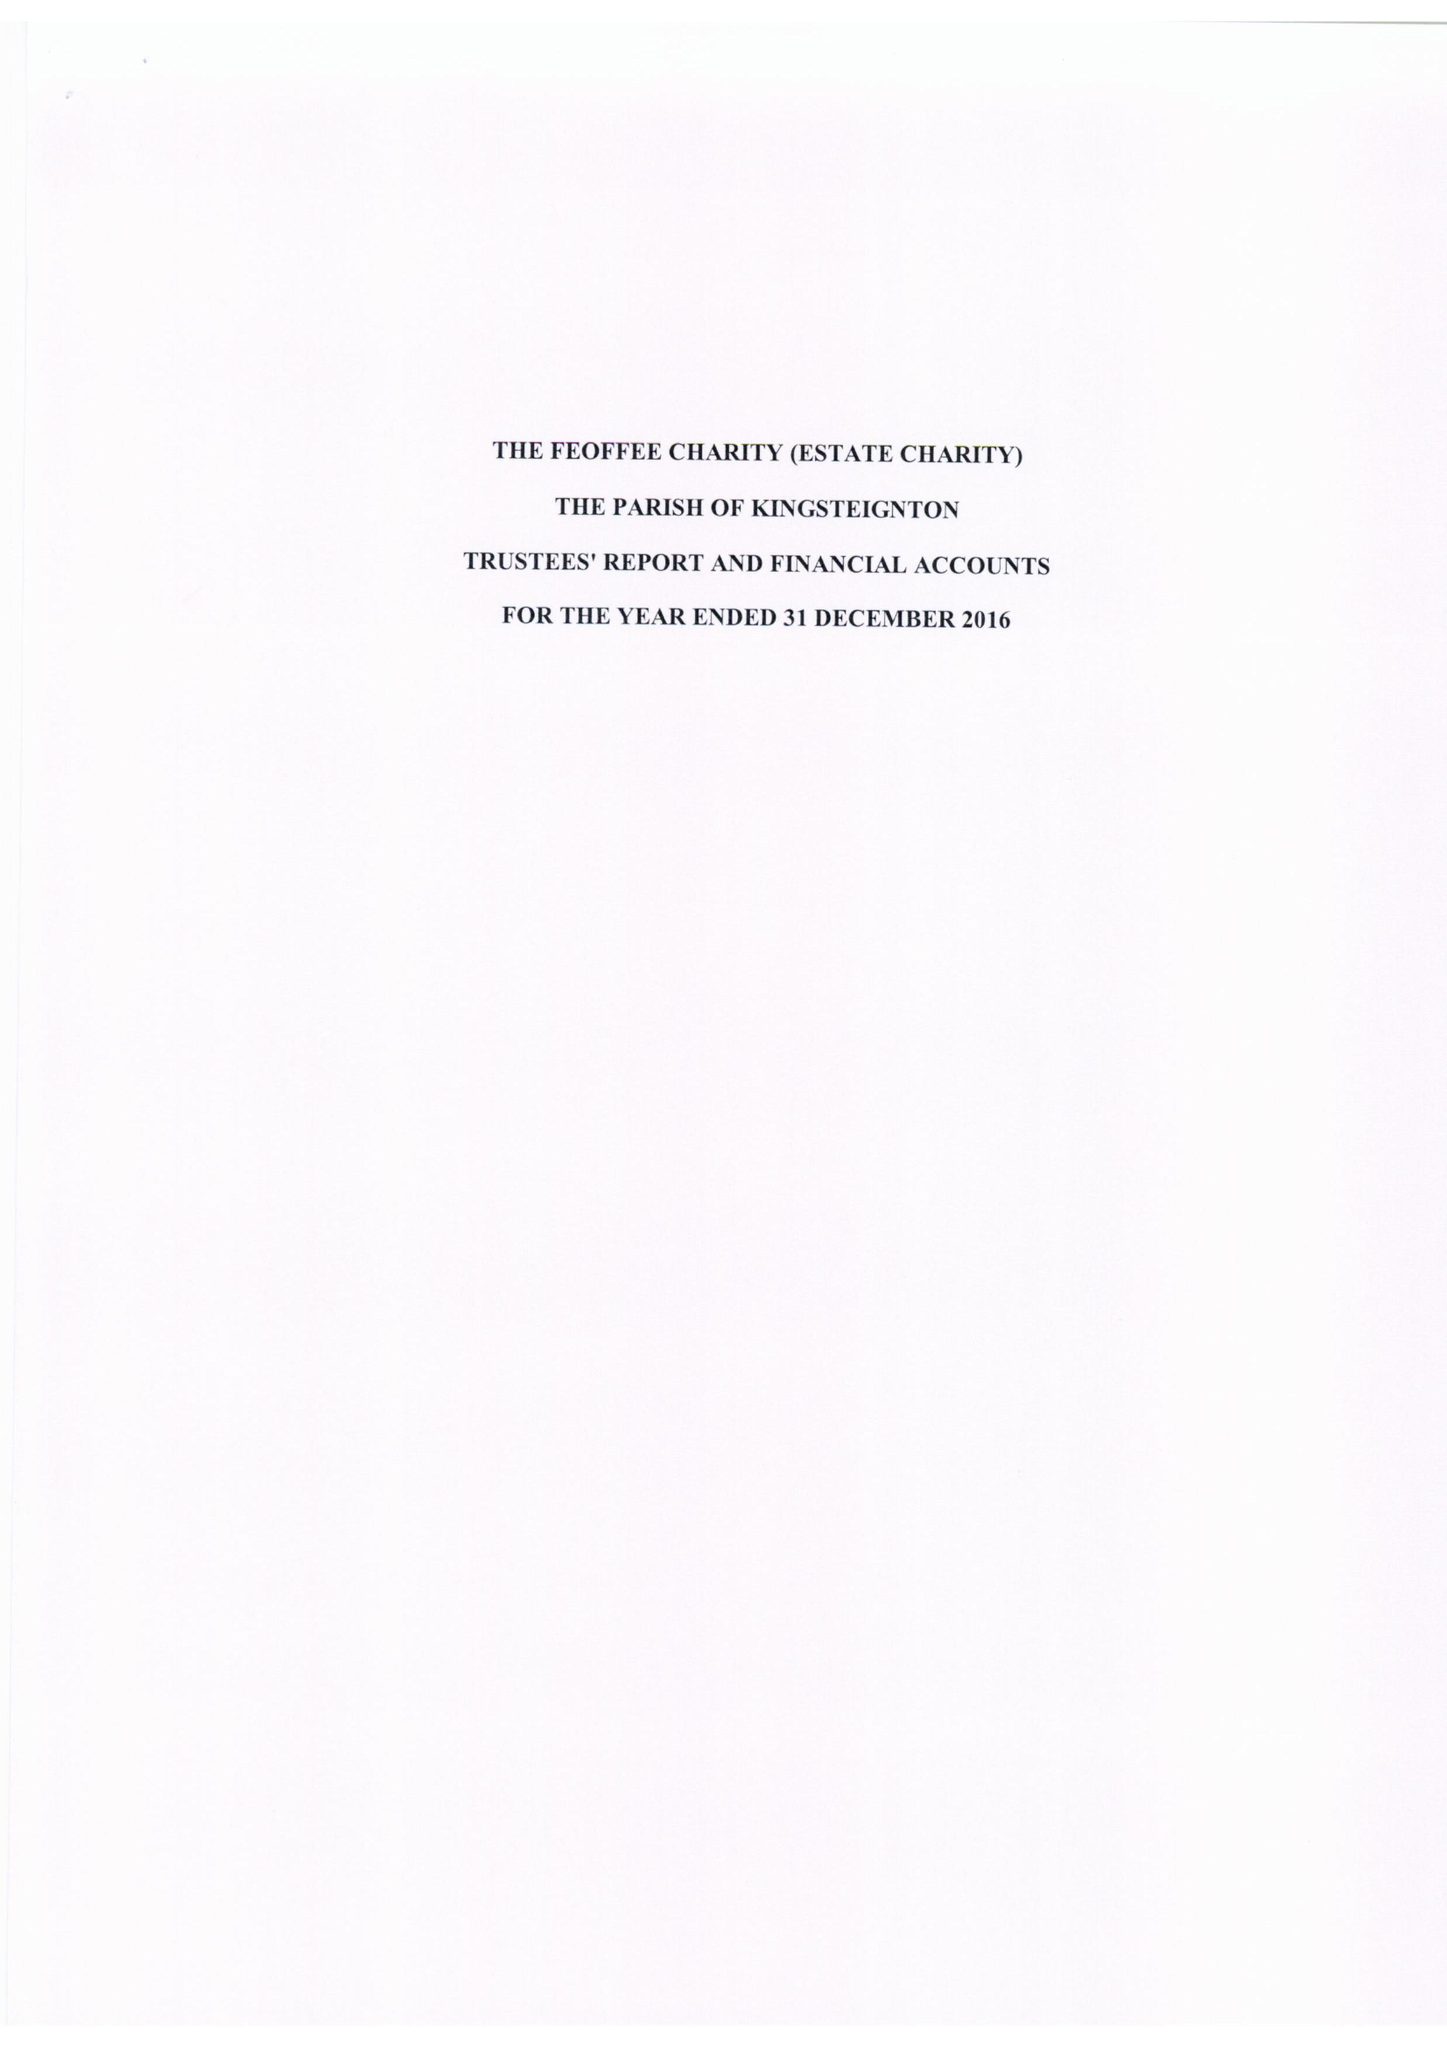What is the value for the address__postcode?
Answer the question using a single word or phrase. TQ3 1AT 